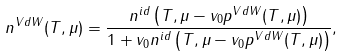Convert formula to latex. <formula><loc_0><loc_0><loc_500><loc_500>n ^ { V d W } ( T , \mu ) = \frac { n ^ { i d } \left ( T , \mu - v _ { 0 } p ^ { V d W } ( T , \mu ) \right ) } { 1 + v _ { 0 } n ^ { i d } \left ( T , \mu - v _ { 0 } p ^ { V d W } ( T , \mu ) \right ) } ,</formula> 